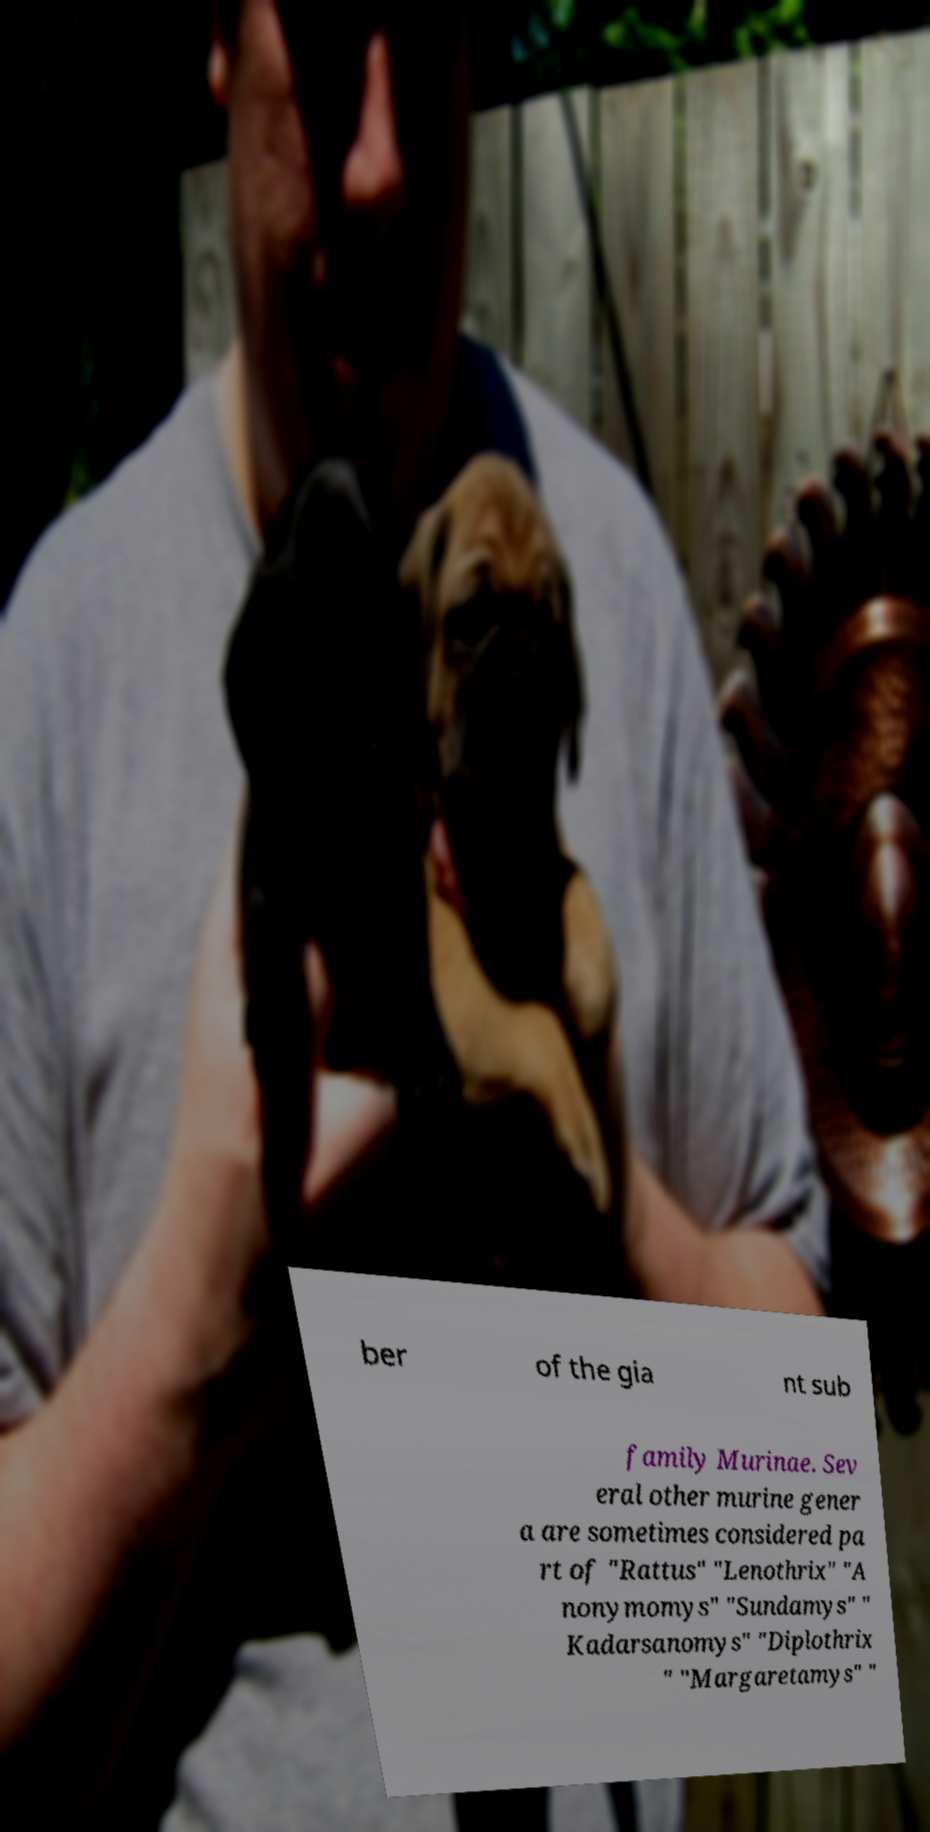Can you read and provide the text displayed in the image?This photo seems to have some interesting text. Can you extract and type it out for me? ber of the gia nt sub family Murinae. Sev eral other murine gener a are sometimes considered pa rt of "Rattus" "Lenothrix" "A nonymomys" "Sundamys" " Kadarsanomys" "Diplothrix " "Margaretamys" " 